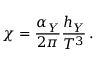<formula> <loc_0><loc_0><loc_500><loc_500>\chi = \frac { \alpha _ { Y } } { 2 \pi } \frac { h _ { Y } } { T ^ { 3 } } \, .</formula> 